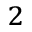Convert formula to latex. <formula><loc_0><loc_0><loc_500><loc_500>^ { 2 }</formula> 